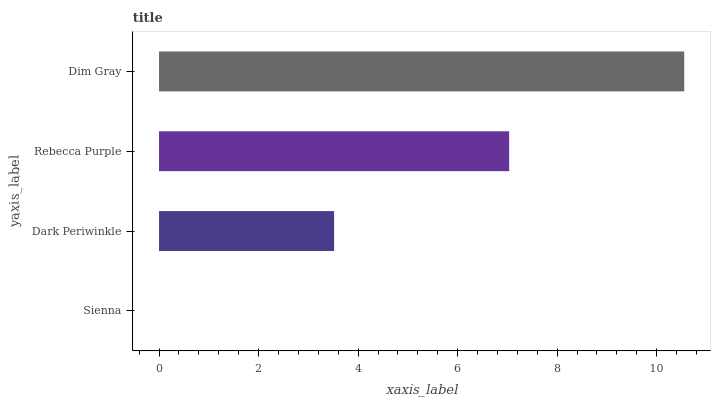Is Sienna the minimum?
Answer yes or no. Yes. Is Dim Gray the maximum?
Answer yes or no. Yes. Is Dark Periwinkle the minimum?
Answer yes or no. No. Is Dark Periwinkle the maximum?
Answer yes or no. No. Is Dark Periwinkle greater than Sienna?
Answer yes or no. Yes. Is Sienna less than Dark Periwinkle?
Answer yes or no. Yes. Is Sienna greater than Dark Periwinkle?
Answer yes or no. No. Is Dark Periwinkle less than Sienna?
Answer yes or no. No. Is Rebecca Purple the high median?
Answer yes or no. Yes. Is Dark Periwinkle the low median?
Answer yes or no. Yes. Is Dark Periwinkle the high median?
Answer yes or no. No. Is Rebecca Purple the low median?
Answer yes or no. No. 